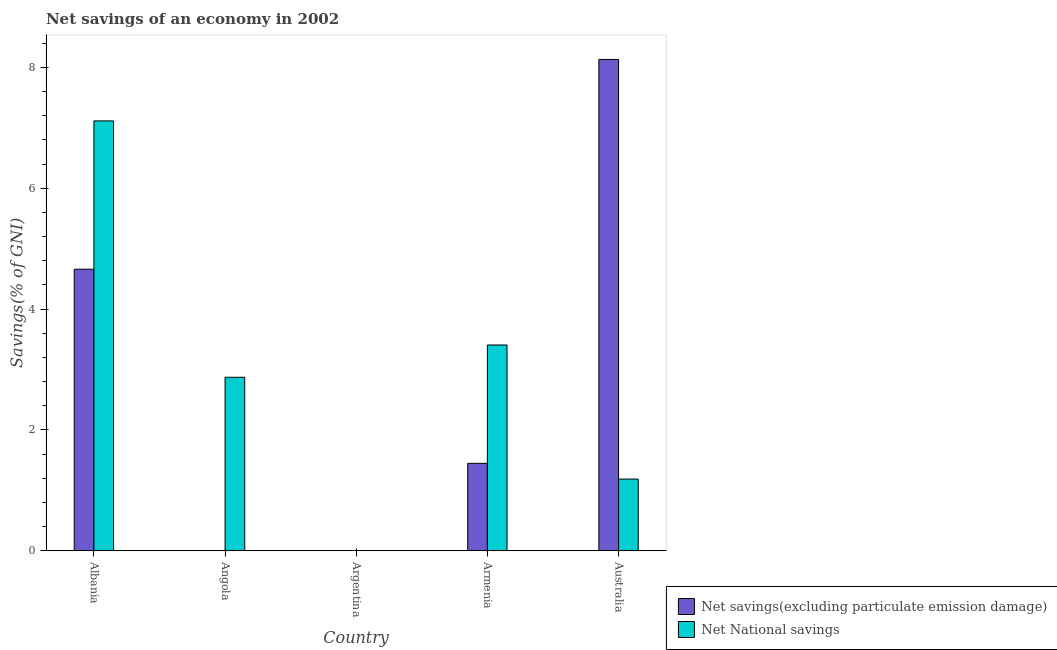Are the number of bars per tick equal to the number of legend labels?
Your answer should be compact. No. Are the number of bars on each tick of the X-axis equal?
Offer a terse response. No. What is the label of the 3rd group of bars from the left?
Your answer should be very brief. Argentina. What is the net savings(excluding particulate emission damage) in Albania?
Give a very brief answer. 4.66. Across all countries, what is the maximum net national savings?
Offer a terse response. 7.11. In which country was the net national savings maximum?
Your answer should be very brief. Albania. What is the total net savings(excluding particulate emission damage) in the graph?
Keep it short and to the point. 14.24. What is the difference between the net national savings in Armenia and that in Australia?
Ensure brevity in your answer.  2.22. What is the difference between the net national savings in Angola and the net savings(excluding particulate emission damage) in Albania?
Make the answer very short. -1.79. What is the average net national savings per country?
Make the answer very short. 2.92. What is the difference between the net savings(excluding particulate emission damage) and net national savings in Armenia?
Your answer should be compact. -1.96. What is the ratio of the net national savings in Albania to that in Angola?
Your response must be concise. 2.48. What is the difference between the highest and the second highest net national savings?
Ensure brevity in your answer.  3.71. What is the difference between the highest and the lowest net savings(excluding particulate emission damage)?
Offer a very short reply. 8.13. In how many countries, is the net national savings greater than the average net national savings taken over all countries?
Offer a terse response. 2. Are all the bars in the graph horizontal?
Give a very brief answer. No. How many countries are there in the graph?
Ensure brevity in your answer.  5. Are the values on the major ticks of Y-axis written in scientific E-notation?
Make the answer very short. No. Does the graph contain grids?
Provide a short and direct response. No. Where does the legend appear in the graph?
Your answer should be very brief. Bottom right. How are the legend labels stacked?
Offer a terse response. Vertical. What is the title of the graph?
Give a very brief answer. Net savings of an economy in 2002. Does "Private funds" appear as one of the legend labels in the graph?
Your answer should be very brief. No. What is the label or title of the Y-axis?
Make the answer very short. Savings(% of GNI). What is the Savings(% of GNI) of Net savings(excluding particulate emission damage) in Albania?
Keep it short and to the point. 4.66. What is the Savings(% of GNI) in Net National savings in Albania?
Provide a succinct answer. 7.11. What is the Savings(% of GNI) of Net savings(excluding particulate emission damage) in Angola?
Your response must be concise. 0. What is the Savings(% of GNI) in Net National savings in Angola?
Offer a very short reply. 2.87. What is the Savings(% of GNI) of Net savings(excluding particulate emission damage) in Argentina?
Your response must be concise. 0. What is the Savings(% of GNI) of Net savings(excluding particulate emission damage) in Armenia?
Ensure brevity in your answer.  1.45. What is the Savings(% of GNI) in Net National savings in Armenia?
Keep it short and to the point. 3.41. What is the Savings(% of GNI) in Net savings(excluding particulate emission damage) in Australia?
Your answer should be very brief. 8.13. What is the Savings(% of GNI) in Net National savings in Australia?
Offer a very short reply. 1.19. Across all countries, what is the maximum Savings(% of GNI) in Net savings(excluding particulate emission damage)?
Your response must be concise. 8.13. Across all countries, what is the maximum Savings(% of GNI) in Net National savings?
Ensure brevity in your answer.  7.11. Across all countries, what is the minimum Savings(% of GNI) in Net savings(excluding particulate emission damage)?
Give a very brief answer. 0. Across all countries, what is the minimum Savings(% of GNI) in Net National savings?
Your response must be concise. 0. What is the total Savings(% of GNI) of Net savings(excluding particulate emission damage) in the graph?
Offer a very short reply. 14.24. What is the total Savings(% of GNI) in Net National savings in the graph?
Give a very brief answer. 14.58. What is the difference between the Savings(% of GNI) in Net National savings in Albania and that in Angola?
Ensure brevity in your answer.  4.24. What is the difference between the Savings(% of GNI) in Net savings(excluding particulate emission damage) in Albania and that in Armenia?
Provide a succinct answer. 3.21. What is the difference between the Savings(% of GNI) in Net National savings in Albania and that in Armenia?
Your response must be concise. 3.71. What is the difference between the Savings(% of GNI) in Net savings(excluding particulate emission damage) in Albania and that in Australia?
Your answer should be compact. -3.47. What is the difference between the Savings(% of GNI) in Net National savings in Albania and that in Australia?
Give a very brief answer. 5.93. What is the difference between the Savings(% of GNI) of Net National savings in Angola and that in Armenia?
Provide a short and direct response. -0.53. What is the difference between the Savings(% of GNI) in Net National savings in Angola and that in Australia?
Make the answer very short. 1.68. What is the difference between the Savings(% of GNI) in Net savings(excluding particulate emission damage) in Armenia and that in Australia?
Ensure brevity in your answer.  -6.68. What is the difference between the Savings(% of GNI) in Net National savings in Armenia and that in Australia?
Provide a short and direct response. 2.22. What is the difference between the Savings(% of GNI) of Net savings(excluding particulate emission damage) in Albania and the Savings(% of GNI) of Net National savings in Angola?
Your response must be concise. 1.79. What is the difference between the Savings(% of GNI) in Net savings(excluding particulate emission damage) in Albania and the Savings(% of GNI) in Net National savings in Armenia?
Provide a short and direct response. 1.25. What is the difference between the Savings(% of GNI) of Net savings(excluding particulate emission damage) in Albania and the Savings(% of GNI) of Net National savings in Australia?
Offer a very short reply. 3.47. What is the difference between the Savings(% of GNI) of Net savings(excluding particulate emission damage) in Armenia and the Savings(% of GNI) of Net National savings in Australia?
Your answer should be compact. 0.26. What is the average Savings(% of GNI) of Net savings(excluding particulate emission damage) per country?
Your response must be concise. 2.85. What is the average Savings(% of GNI) of Net National savings per country?
Offer a very short reply. 2.92. What is the difference between the Savings(% of GNI) in Net savings(excluding particulate emission damage) and Savings(% of GNI) in Net National savings in Albania?
Give a very brief answer. -2.45. What is the difference between the Savings(% of GNI) of Net savings(excluding particulate emission damage) and Savings(% of GNI) of Net National savings in Armenia?
Your answer should be very brief. -1.96. What is the difference between the Savings(% of GNI) in Net savings(excluding particulate emission damage) and Savings(% of GNI) in Net National savings in Australia?
Your answer should be very brief. 6.94. What is the ratio of the Savings(% of GNI) in Net National savings in Albania to that in Angola?
Make the answer very short. 2.48. What is the ratio of the Savings(% of GNI) of Net savings(excluding particulate emission damage) in Albania to that in Armenia?
Offer a very short reply. 3.22. What is the ratio of the Savings(% of GNI) in Net National savings in Albania to that in Armenia?
Make the answer very short. 2.09. What is the ratio of the Savings(% of GNI) in Net savings(excluding particulate emission damage) in Albania to that in Australia?
Provide a short and direct response. 0.57. What is the ratio of the Savings(% of GNI) in Net National savings in Albania to that in Australia?
Offer a terse response. 5.99. What is the ratio of the Savings(% of GNI) of Net National savings in Angola to that in Armenia?
Make the answer very short. 0.84. What is the ratio of the Savings(% of GNI) in Net National savings in Angola to that in Australia?
Your answer should be very brief. 2.42. What is the ratio of the Savings(% of GNI) of Net savings(excluding particulate emission damage) in Armenia to that in Australia?
Provide a succinct answer. 0.18. What is the ratio of the Savings(% of GNI) of Net National savings in Armenia to that in Australia?
Your answer should be compact. 2.87. What is the difference between the highest and the second highest Savings(% of GNI) in Net savings(excluding particulate emission damage)?
Provide a succinct answer. 3.47. What is the difference between the highest and the second highest Savings(% of GNI) of Net National savings?
Offer a terse response. 3.71. What is the difference between the highest and the lowest Savings(% of GNI) of Net savings(excluding particulate emission damage)?
Keep it short and to the point. 8.13. What is the difference between the highest and the lowest Savings(% of GNI) of Net National savings?
Offer a terse response. 7.11. 